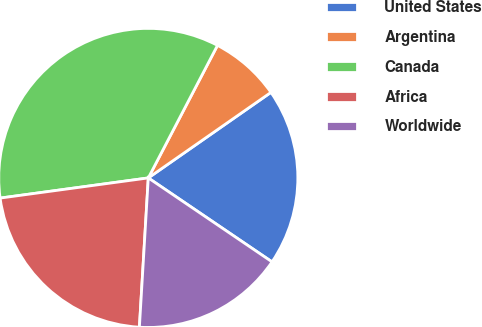Convert chart to OTSL. <chart><loc_0><loc_0><loc_500><loc_500><pie_chart><fcel>United States<fcel>Argentina<fcel>Canada<fcel>Africa<fcel>Worldwide<nl><fcel>19.18%<fcel>7.65%<fcel>34.81%<fcel>21.9%<fcel>16.46%<nl></chart> 